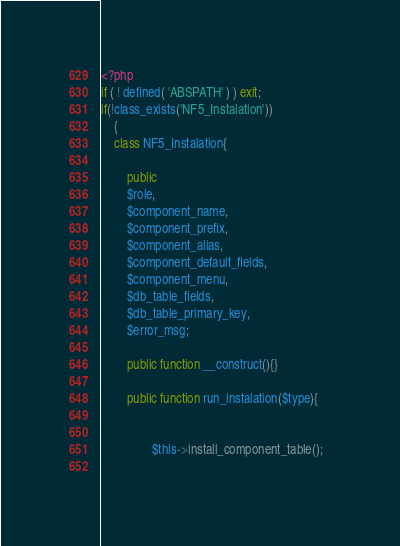<code> <loc_0><loc_0><loc_500><loc_500><_PHP_><?php
if ( ! defined( 'ABSPATH' ) ) exit;
if(!class_exists('NF5_Instalation'))
	{
	class NF5_Instalation{
		
		public 
		$role,
		$component_name,
		$component_prefix,
		$component_alias,
		$component_default_fields,
		$component_menu,
		$db_table_fields, 
		$db_table_primary_key,
		$error_msg;
	
		public function __construct(){}
		
		public function run_instalation($type){	
				
				
				$this->install_component_table();
				</code> 